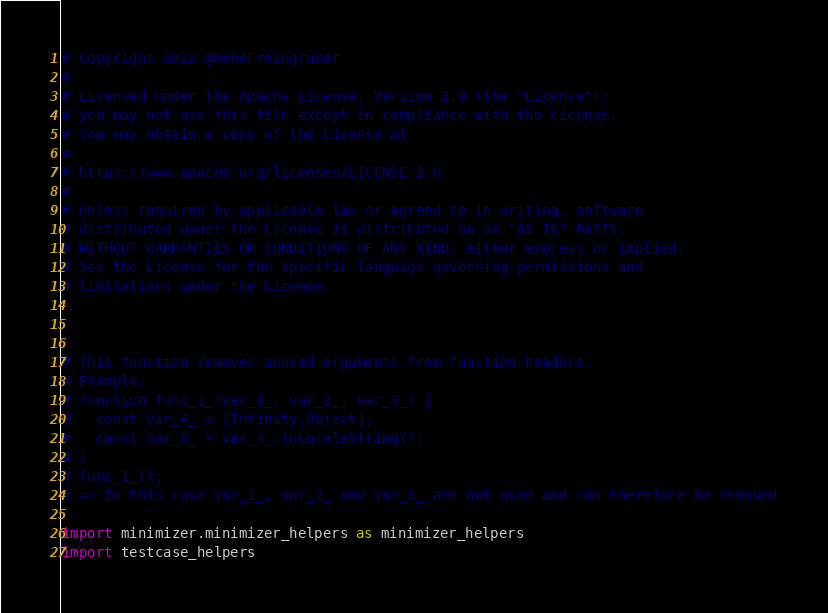Convert code to text. <code><loc_0><loc_0><loc_500><loc_500><_Python_># Copyright 2022 @ReneFreingruber
#
# Licensed under the Apache License, Version 2.0 (the "License");
# you may not use this file except in compliance with the License.
# You may obtain a copy of the License at
#
# https://www.apache.org/licenses/LICENSE-2.0
#
# Unless required by applicable law or agreed to in writing, software
# distributed under the License is distributed on an "AS IS" BASIS,
# WITHOUT WARRANTIES OR CONDITIONS OF ANY KIND, either express or implied.
# See the License for the specific language governing permissions and
# limitations under the License.



# This function removes unused arguments from function headers.
# Example:
# function func_1_(var_1_, var_2_, var_3_) {
#   const var_4_ = [Infinity,Object];
#   const var_5_ = var_4_.toLocaleString();
# }
# func_1_();
# => In this case var_1_, var_2_ and var_3_ are not used and can therefore be removed

import minimizer.minimizer_helpers as minimizer_helpers
import testcase_helpers

</code> 